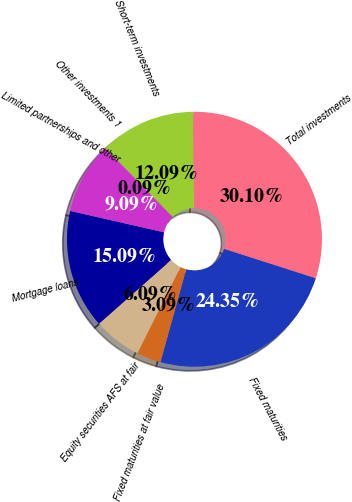Convert chart. <chart><loc_0><loc_0><loc_500><loc_500><pie_chart><fcel>Fixed maturities<fcel>Fixed maturities at fair value<fcel>Equity securities AFS at fair<fcel>Mortgage loans<fcel>Limited partnerships and other<fcel>Other investments 1<fcel>Short-term investments<fcel>Total investments<nl><fcel>24.35%<fcel>3.09%<fcel>6.09%<fcel>15.09%<fcel>9.09%<fcel>0.09%<fcel>12.09%<fcel>30.1%<nl></chart> 